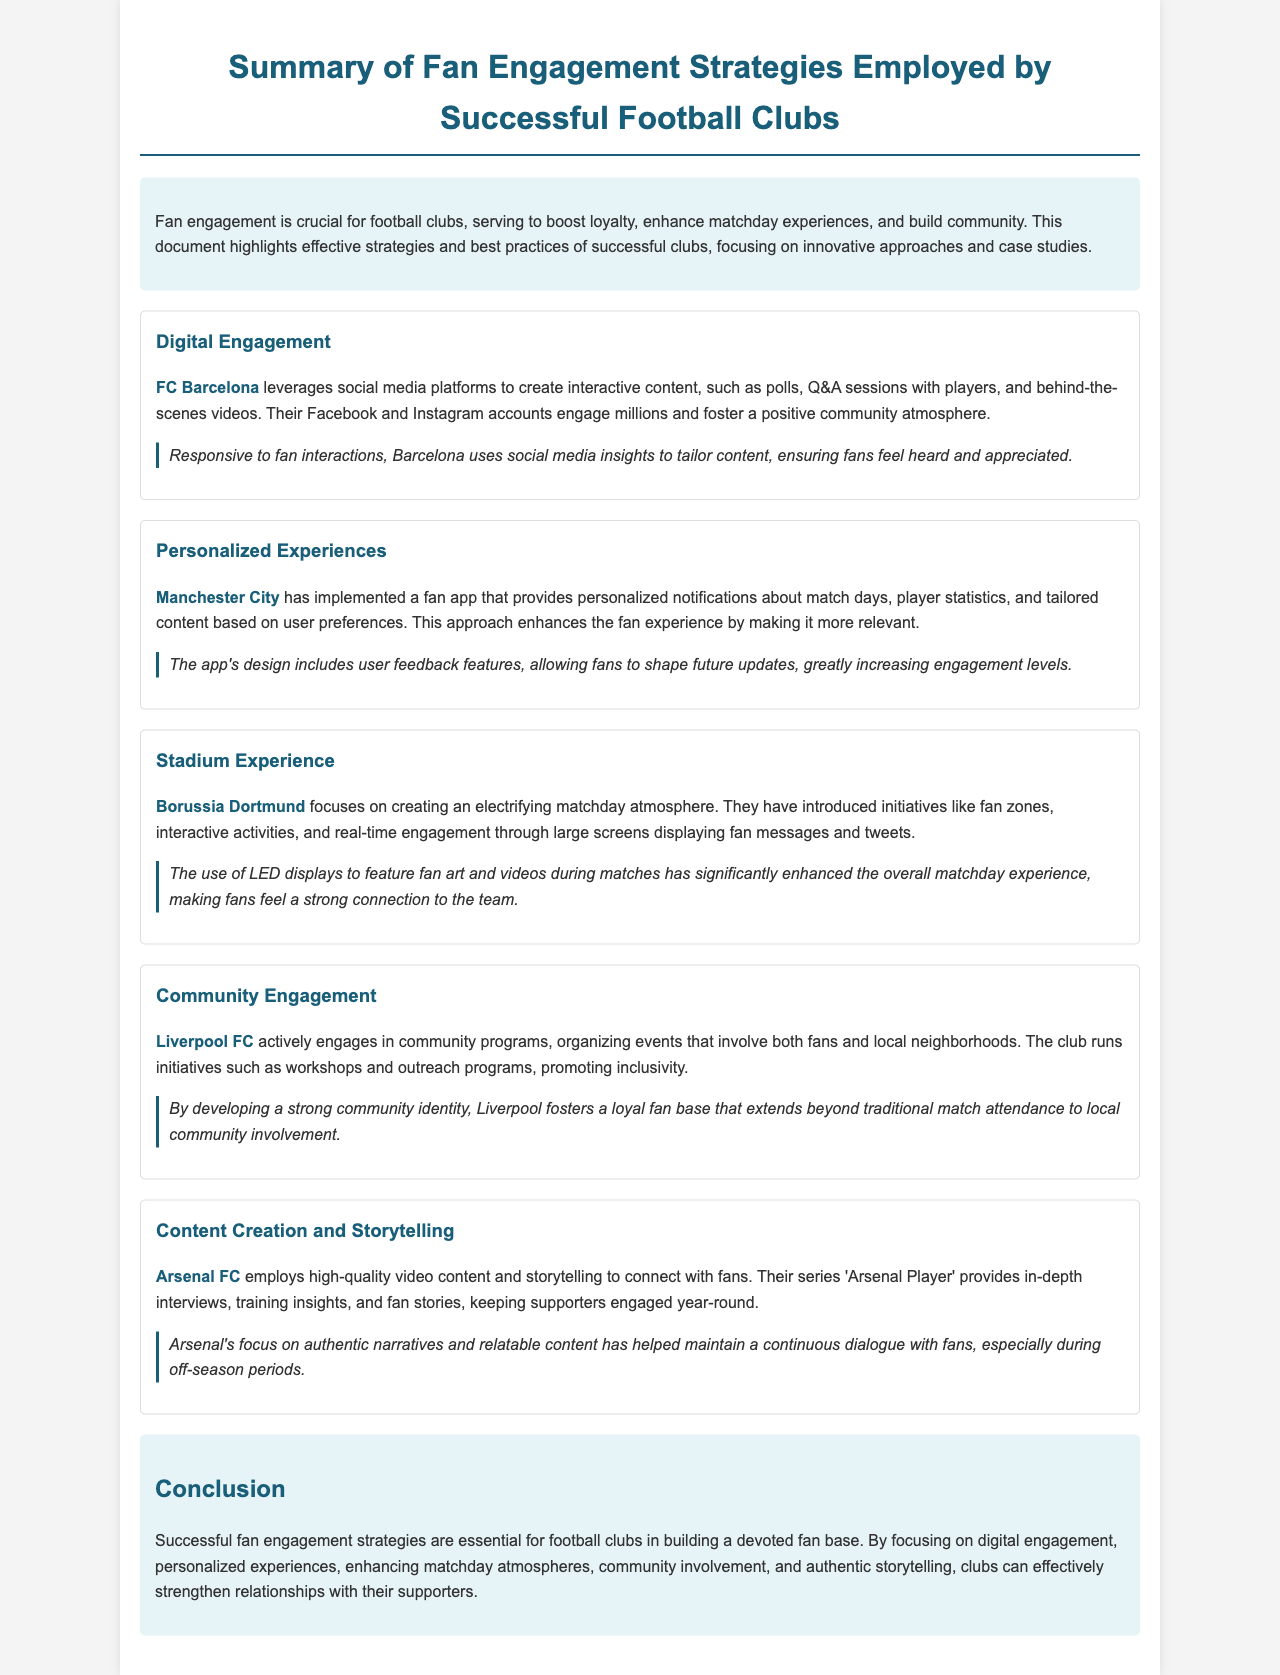What club leverages social media for fan engagement? The document states that FC Barcelona utilizes social media platforms for engaging content, such as polls and behind-the-scenes videos.
Answer: FC Barcelona Which club has implemented a fan app for personalized experiences? The report mentions that Manchester City has created a fan app that offers personalized notifications and tailored content.
Answer: Manchester City What is one of Borussia Dortmund's initiatives to enhance the stadium experience? The document highlights Borussia Dortmund introducing fan zones and real-time engagement through large screens during matches.
Answer: Fan zones Which club organizes community programs and outreach? The document indicates that Liverpool FC actively engages in community programs and local neighborhood events.
Answer: Liverpool FC What type of content does Arsenal FC use to connect with fans? According to the report, Arsenal FC employs high-quality video content and storytelling to engage their supporters.
Answer: Video content What is a best practice of FC Barcelona in engaging with fans? The report states that Barcelona uses social media insights to tailor content in response to fan interactions.
Answer: Tailoring content What is the primary focus of successful fan engagement strategies? The conclusion emphasizes that successful fan engagement strategies are essential for building a devoted fan base.
Answer: Devoted fan base How many key strategies are highlighted in the report? The document details five distinct strategies of fan engagement employed by successful clubs.
Answer: Five What is the focus of community engagement strategies highlighted by Liverpool FC? The document mentions that Liverpool FC promotes inclusivity through community workshops and outreach programs.
Answer: Inclusivity 